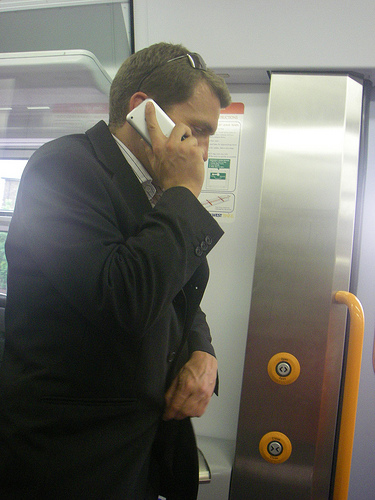If you could add a whimsical element to this image, what would it be? Imagine if the man on the phone suddenly received a call from an intergalactic space station. The train's metallic panel starts lighting up with various colors, and the buttons start floating. The man’s suit transforms into a sleek astronaut gear, and the train becomes a part of a spaceship journeying through nebulas and star clusters. 